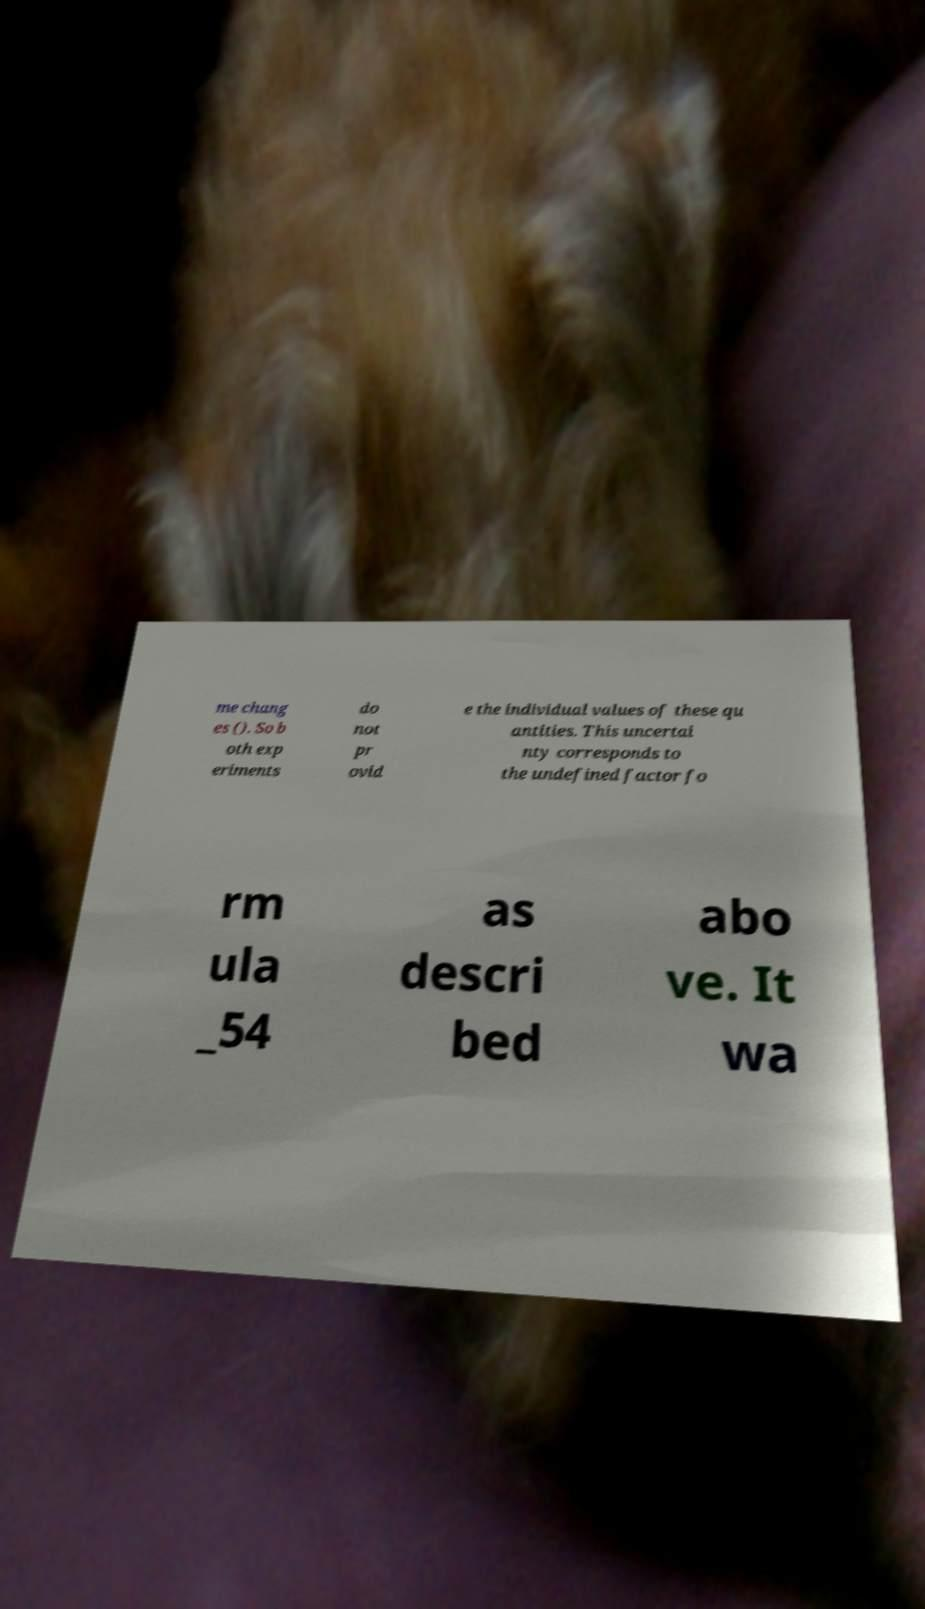Please read and relay the text visible in this image. What does it say? me chang es (). So b oth exp eriments do not pr ovid e the individual values of these qu antities. This uncertai nty corresponds to the undefined factor fo rm ula _54 as descri bed abo ve. It wa 